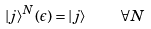Convert formula to latex. <formula><loc_0><loc_0><loc_500><loc_500>| j \rangle ^ { N } ( \epsilon ) = | j \rangle \quad \forall N</formula> 